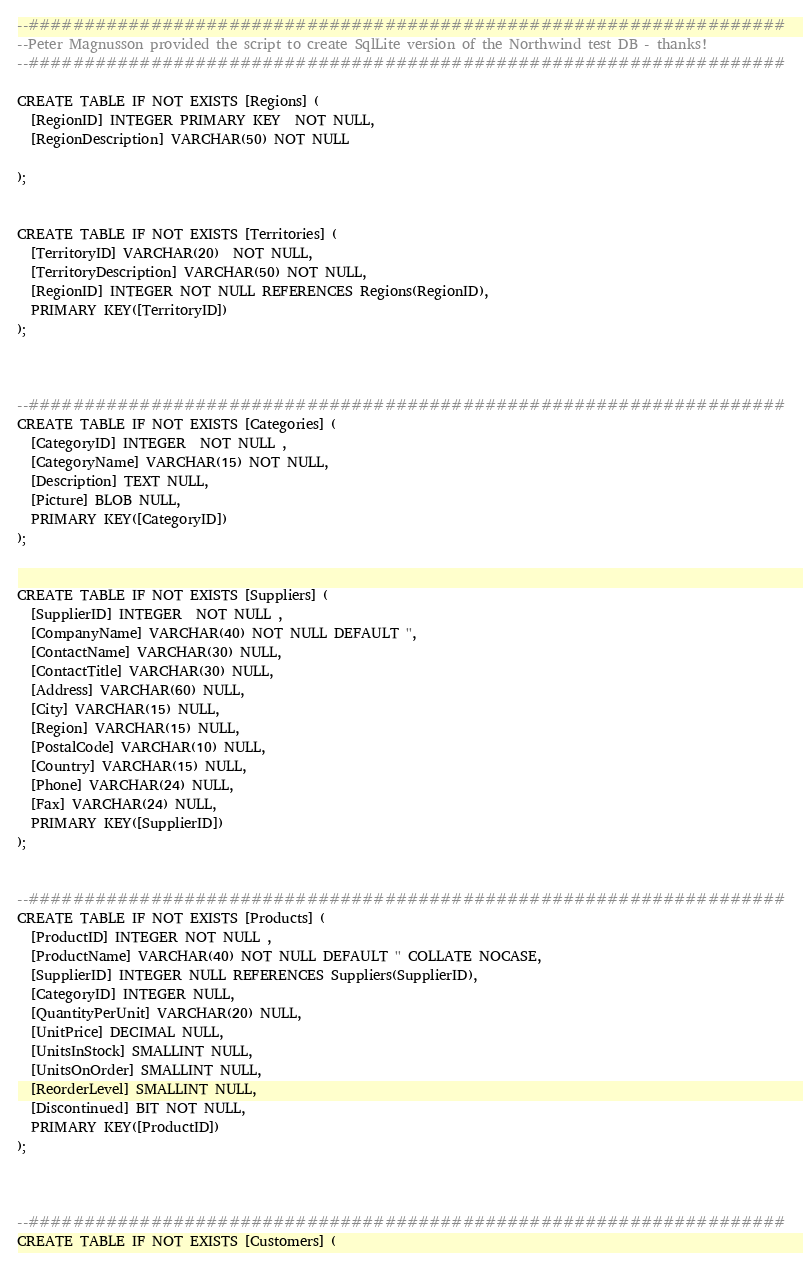Convert code to text. <code><loc_0><loc_0><loc_500><loc_500><_SQL_>--####################################################################
--Peter Magnusson provided the script to create SqlLite version of the Northwind test DB - thanks!
--####################################################################

CREATE TABLE IF NOT EXISTS [Regions] (
  [RegionID] INTEGER PRIMARY KEY  NOT NULL,
  [RegionDescription] VARCHAR(50) NOT NULL
  
);


CREATE TABLE IF NOT EXISTS [Territories] (
  [TerritoryID] VARCHAR(20)  NOT NULL,
  [TerritoryDescription] VARCHAR(50) NOT NULL,
  [RegionID] INTEGER NOT NULL REFERENCES Regions(RegionID),
  PRIMARY KEY([TerritoryID])
);



--####################################################################
CREATE TABLE IF NOT EXISTS [Categories] (
  [CategoryID] INTEGER  NOT NULL ,
  [CategoryName] VARCHAR(15) NOT NULL,
  [Description] TEXT NULL,
  [Picture] BLOB NULL,
  PRIMARY KEY([CategoryID])
);


CREATE TABLE IF NOT EXISTS [Suppliers] (
  [SupplierID] INTEGER  NOT NULL ,
  [CompanyName] VARCHAR(40) NOT NULL DEFAULT '',
  [ContactName] VARCHAR(30) NULL,
  [ContactTitle] VARCHAR(30) NULL,
  [Address] VARCHAR(60) NULL,
  [City] VARCHAR(15) NULL,
  [Region] VARCHAR(15) NULL,
  [PostalCode] VARCHAR(10) NULL,
  [Country] VARCHAR(15) NULL,
  [Phone] VARCHAR(24) NULL,
  [Fax] VARCHAR(24) NULL,
  PRIMARY KEY([SupplierID])
);


--####################################################################
CREATE TABLE IF NOT EXISTS [Products] (
  [ProductID] INTEGER NOT NULL ,
  [ProductName] VARCHAR(40) NOT NULL DEFAULT '' COLLATE NOCASE,
  [SupplierID] INTEGER NULL REFERENCES Suppliers(SupplierID),
  [CategoryID] INTEGER NULL,
  [QuantityPerUnit] VARCHAR(20) NULL,
  [UnitPrice] DECIMAL NULL,
  [UnitsInStock] SMALLINT NULL,
  [UnitsOnOrder] SMALLINT NULL,
  [ReorderLevel] SMALLINT NULL,
  [Discontinued] BIT NOT NULL,
  PRIMARY KEY([ProductID])
);



--####################################################################
CREATE TABLE IF NOT EXISTS [Customers] (</code> 